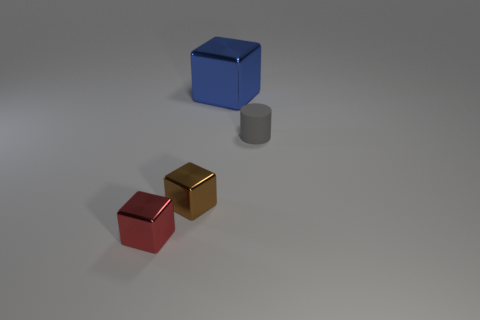If these objects were used in a game, what could be their possible roles or functions? In a game setting, these objects could serve various roles. The blue and red cubes might act as collectible items for points or resources, with the red cube being a lesser value due to its smaller size. The gold cube, with its shiny appearance, could represent a rare or high-value item. The gray matte cylinder might be an obstacle to navigate around or a piece of a puzzle element that needs to be moved to a specific location to unlock a pathway or reveal a hidden treasure. 